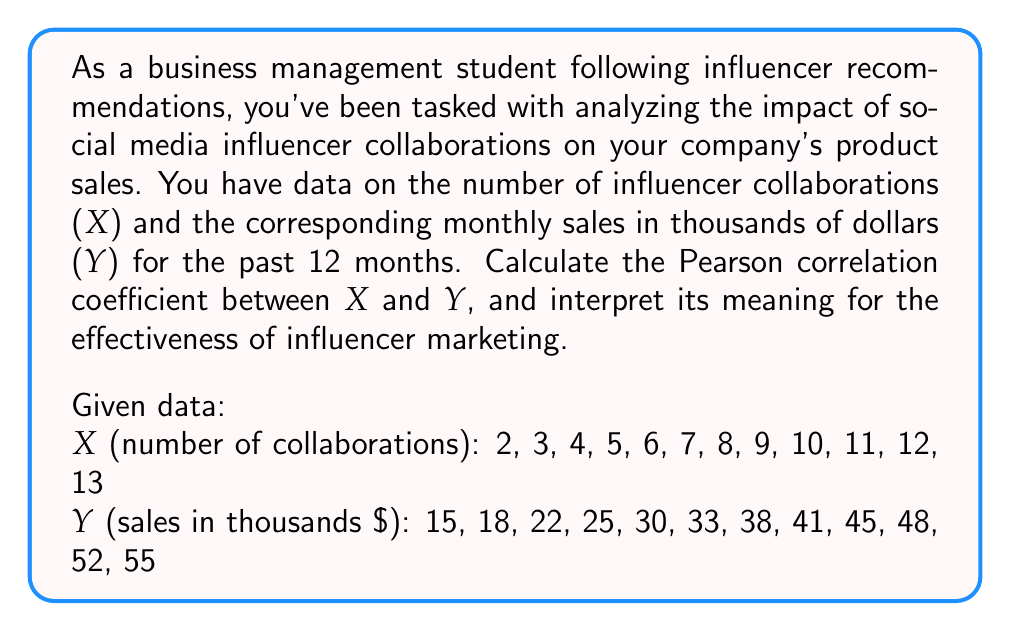Solve this math problem. To calculate the Pearson correlation coefficient (r) between the number of influencer collaborations (X) and monthly sales (Y), we'll use the formula:

$$ r = \frac{n\sum xy - \sum x \sum y}{\sqrt{[n\sum x^2 - (\sum x)^2][n\sum y^2 - (\sum y)^2]}} $$

Where n is the number of data points (12 in this case).

Step 1: Calculate the sums and squared sums:
$\sum x = 90$
$\sum y = 422$
$\sum x^2 = 870$
$\sum y^2 = 15,548$
$\sum xy = 4,089$

Step 2: Apply the formula:

$$ r = \frac{12(4,089) - (90)(422)}{\sqrt{[12(870) - 90^2][12(15,548) - 422^2]}} $$

$$ r = \frac{49,068 - 37,980}{\sqrt{(10,440 - 8,100)(186,576 - 178,084)}} $$

$$ r = \frac{11,088}{\sqrt{2,340 \times 8,492}} $$

$$ r = \frac{11,088}{\sqrt{19,871,280}} $$

$$ r = \frac{11,088}{4,457.71} $$

$$ r \approx 0.9979 $$

Interpretation: The Pearson correlation coefficient of approximately 0.9979 indicates a very strong positive correlation between the number of influencer collaborations and monthly sales. This suggests that as the number of influencer collaborations increases, there is a strong tendency for sales to increase as well.

For a business management student following influencer recommendations, this result demonstrates the potentially high effectiveness of influencer marketing in driving sales. It supports the strategy of collaborating with social media influencers to boost product visibility and sales performance.

However, it's important to note that correlation does not imply causation. Other factors may also contribute to the increase in sales, and further analysis (such as regression analysis) would be needed to determine the exact relationship and predictive power of influencer collaborations on sales.
Answer: The Pearson correlation coefficient is approximately 0.9979, indicating a very strong positive correlation between the number of influencer collaborations and monthly sales. 